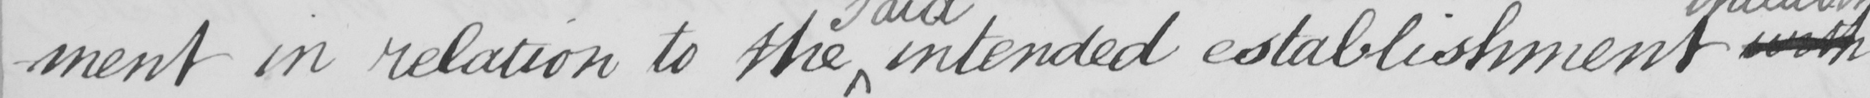Please transcribe the handwritten text in this image. -ment in relation to the intended establishment with 